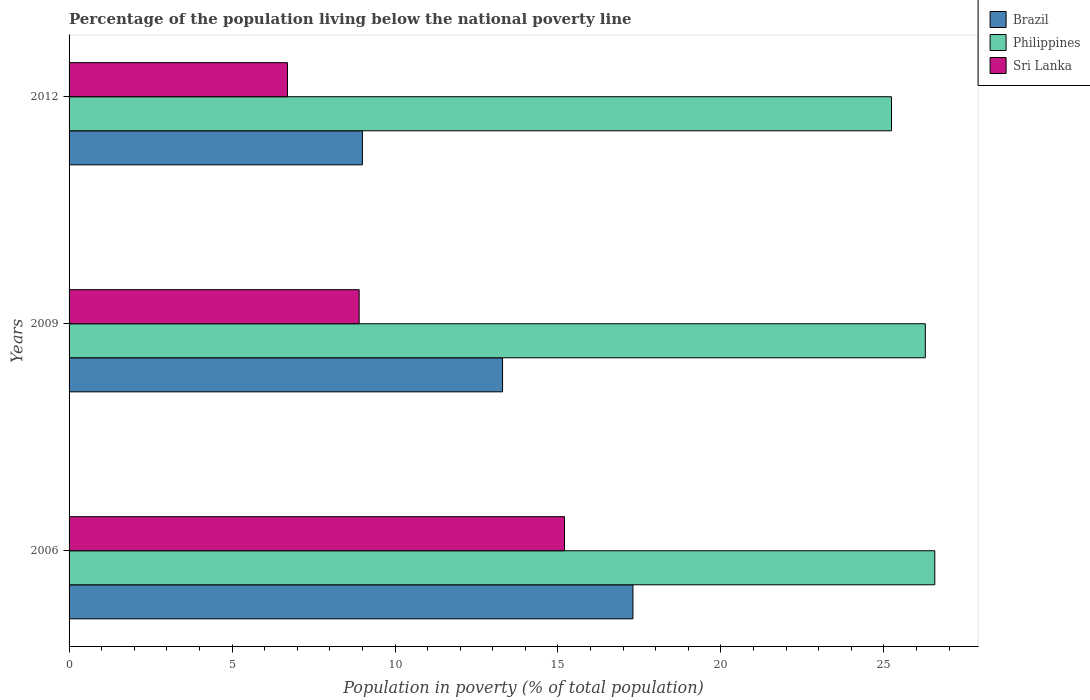How many groups of bars are there?
Ensure brevity in your answer.  3. Are the number of bars per tick equal to the number of legend labels?
Provide a short and direct response. Yes. What is the label of the 2nd group of bars from the top?
Your answer should be compact. 2009. In how many cases, is the number of bars for a given year not equal to the number of legend labels?
Ensure brevity in your answer.  0. What is the percentage of the population living below the national poverty line in Sri Lanka in 2009?
Provide a succinct answer. 8.9. Across all years, what is the maximum percentage of the population living below the national poverty line in Philippines?
Keep it short and to the point. 26.56. In which year was the percentage of the population living below the national poverty line in Sri Lanka maximum?
Provide a succinct answer. 2006. What is the total percentage of the population living below the national poverty line in Brazil in the graph?
Your answer should be compact. 39.6. What is the difference between the percentage of the population living below the national poverty line in Sri Lanka in 2006 and that in 2009?
Your response must be concise. 6.3. What is the difference between the percentage of the population living below the national poverty line in Brazil in 2006 and the percentage of the population living below the national poverty line in Sri Lanka in 2009?
Keep it short and to the point. 8.4. What is the average percentage of the population living below the national poverty line in Sri Lanka per year?
Ensure brevity in your answer.  10.27. In the year 2012, what is the difference between the percentage of the population living below the national poverty line in Philippines and percentage of the population living below the national poverty line in Brazil?
Your response must be concise. 16.23. In how many years, is the percentage of the population living below the national poverty line in Philippines greater than 11 %?
Provide a succinct answer. 3. What is the ratio of the percentage of the population living below the national poverty line in Brazil in 2006 to that in 2009?
Keep it short and to the point. 1.3. Is the percentage of the population living below the national poverty line in Sri Lanka in 2009 less than that in 2012?
Ensure brevity in your answer.  No. Is the difference between the percentage of the population living below the national poverty line in Philippines in 2006 and 2012 greater than the difference between the percentage of the population living below the national poverty line in Brazil in 2006 and 2012?
Offer a very short reply. No. What is the difference between the highest and the second highest percentage of the population living below the national poverty line in Brazil?
Your answer should be compact. 4. In how many years, is the percentage of the population living below the national poverty line in Brazil greater than the average percentage of the population living below the national poverty line in Brazil taken over all years?
Provide a short and direct response. 2. Is the sum of the percentage of the population living below the national poverty line in Brazil in 2006 and 2012 greater than the maximum percentage of the population living below the national poverty line in Sri Lanka across all years?
Make the answer very short. Yes. What does the 3rd bar from the bottom in 2006 represents?
Your response must be concise. Sri Lanka. Is it the case that in every year, the sum of the percentage of the population living below the national poverty line in Sri Lanka and percentage of the population living below the national poverty line in Philippines is greater than the percentage of the population living below the national poverty line in Brazil?
Provide a short and direct response. Yes. How many bars are there?
Your answer should be compact. 9. Are all the bars in the graph horizontal?
Offer a very short reply. Yes. How many years are there in the graph?
Offer a terse response. 3. What is the difference between two consecutive major ticks on the X-axis?
Provide a succinct answer. 5. Does the graph contain any zero values?
Your response must be concise. No. What is the title of the graph?
Your answer should be compact. Percentage of the population living below the national poverty line. Does "Central Europe" appear as one of the legend labels in the graph?
Offer a very short reply. No. What is the label or title of the X-axis?
Your answer should be very brief. Population in poverty (% of total population). What is the Population in poverty (% of total population) of Brazil in 2006?
Offer a terse response. 17.3. What is the Population in poverty (% of total population) in Philippines in 2006?
Offer a terse response. 26.56. What is the Population in poverty (% of total population) in Sri Lanka in 2006?
Provide a short and direct response. 15.2. What is the Population in poverty (% of total population) of Philippines in 2009?
Your answer should be compact. 26.27. What is the Population in poverty (% of total population) in Brazil in 2012?
Offer a terse response. 9. What is the Population in poverty (% of total population) in Philippines in 2012?
Ensure brevity in your answer.  25.23. Across all years, what is the maximum Population in poverty (% of total population) in Philippines?
Provide a succinct answer. 26.56. Across all years, what is the maximum Population in poverty (% of total population) in Sri Lanka?
Provide a short and direct response. 15.2. Across all years, what is the minimum Population in poverty (% of total population) in Brazil?
Offer a terse response. 9. Across all years, what is the minimum Population in poverty (% of total population) in Philippines?
Ensure brevity in your answer.  25.23. What is the total Population in poverty (% of total population) in Brazil in the graph?
Keep it short and to the point. 39.6. What is the total Population in poverty (% of total population) of Philippines in the graph?
Your answer should be compact. 78.07. What is the total Population in poverty (% of total population) of Sri Lanka in the graph?
Offer a very short reply. 30.8. What is the difference between the Population in poverty (% of total population) in Philippines in 2006 and that in 2009?
Ensure brevity in your answer.  0.29. What is the difference between the Population in poverty (% of total population) in Philippines in 2006 and that in 2012?
Offer a terse response. 1.33. What is the difference between the Population in poverty (% of total population) in Philippines in 2009 and that in 2012?
Offer a very short reply. 1.04. What is the difference between the Population in poverty (% of total population) in Sri Lanka in 2009 and that in 2012?
Your answer should be compact. 2.2. What is the difference between the Population in poverty (% of total population) in Brazil in 2006 and the Population in poverty (% of total population) in Philippines in 2009?
Keep it short and to the point. -8.97. What is the difference between the Population in poverty (% of total population) of Brazil in 2006 and the Population in poverty (% of total population) of Sri Lanka in 2009?
Keep it short and to the point. 8.4. What is the difference between the Population in poverty (% of total population) in Philippines in 2006 and the Population in poverty (% of total population) in Sri Lanka in 2009?
Your answer should be compact. 17.66. What is the difference between the Population in poverty (% of total population) in Brazil in 2006 and the Population in poverty (% of total population) in Philippines in 2012?
Ensure brevity in your answer.  -7.93. What is the difference between the Population in poverty (% of total population) of Brazil in 2006 and the Population in poverty (% of total population) of Sri Lanka in 2012?
Ensure brevity in your answer.  10.6. What is the difference between the Population in poverty (% of total population) in Philippines in 2006 and the Population in poverty (% of total population) in Sri Lanka in 2012?
Give a very brief answer. 19.86. What is the difference between the Population in poverty (% of total population) of Brazil in 2009 and the Population in poverty (% of total population) of Philippines in 2012?
Offer a very short reply. -11.93. What is the difference between the Population in poverty (% of total population) of Philippines in 2009 and the Population in poverty (% of total population) of Sri Lanka in 2012?
Your answer should be very brief. 19.57. What is the average Population in poverty (% of total population) of Brazil per year?
Give a very brief answer. 13.2. What is the average Population in poverty (% of total population) in Philippines per year?
Keep it short and to the point. 26.02. What is the average Population in poverty (% of total population) in Sri Lanka per year?
Provide a short and direct response. 10.27. In the year 2006, what is the difference between the Population in poverty (% of total population) in Brazil and Population in poverty (% of total population) in Philippines?
Provide a succinct answer. -9.26. In the year 2006, what is the difference between the Population in poverty (% of total population) of Brazil and Population in poverty (% of total population) of Sri Lanka?
Provide a succinct answer. 2.1. In the year 2006, what is the difference between the Population in poverty (% of total population) in Philippines and Population in poverty (% of total population) in Sri Lanka?
Offer a terse response. 11.36. In the year 2009, what is the difference between the Population in poverty (% of total population) of Brazil and Population in poverty (% of total population) of Philippines?
Give a very brief answer. -12.97. In the year 2009, what is the difference between the Population in poverty (% of total population) of Brazil and Population in poverty (% of total population) of Sri Lanka?
Offer a very short reply. 4.4. In the year 2009, what is the difference between the Population in poverty (% of total population) of Philippines and Population in poverty (% of total population) of Sri Lanka?
Your response must be concise. 17.37. In the year 2012, what is the difference between the Population in poverty (% of total population) of Brazil and Population in poverty (% of total population) of Philippines?
Give a very brief answer. -16.23. In the year 2012, what is the difference between the Population in poverty (% of total population) of Brazil and Population in poverty (% of total population) of Sri Lanka?
Your response must be concise. 2.3. In the year 2012, what is the difference between the Population in poverty (% of total population) in Philippines and Population in poverty (% of total population) in Sri Lanka?
Ensure brevity in your answer.  18.53. What is the ratio of the Population in poverty (% of total population) in Brazil in 2006 to that in 2009?
Offer a very short reply. 1.3. What is the ratio of the Population in poverty (% of total population) in Philippines in 2006 to that in 2009?
Provide a succinct answer. 1.01. What is the ratio of the Population in poverty (% of total population) of Sri Lanka in 2006 to that in 2009?
Your response must be concise. 1.71. What is the ratio of the Population in poverty (% of total population) in Brazil in 2006 to that in 2012?
Ensure brevity in your answer.  1.92. What is the ratio of the Population in poverty (% of total population) in Philippines in 2006 to that in 2012?
Offer a terse response. 1.05. What is the ratio of the Population in poverty (% of total population) of Sri Lanka in 2006 to that in 2012?
Offer a very short reply. 2.27. What is the ratio of the Population in poverty (% of total population) of Brazil in 2009 to that in 2012?
Provide a short and direct response. 1.48. What is the ratio of the Population in poverty (% of total population) in Philippines in 2009 to that in 2012?
Give a very brief answer. 1.04. What is the ratio of the Population in poverty (% of total population) in Sri Lanka in 2009 to that in 2012?
Give a very brief answer. 1.33. What is the difference between the highest and the second highest Population in poverty (% of total population) of Philippines?
Your response must be concise. 0.29. What is the difference between the highest and the second highest Population in poverty (% of total population) in Sri Lanka?
Give a very brief answer. 6.3. What is the difference between the highest and the lowest Population in poverty (% of total population) of Philippines?
Provide a succinct answer. 1.33. 